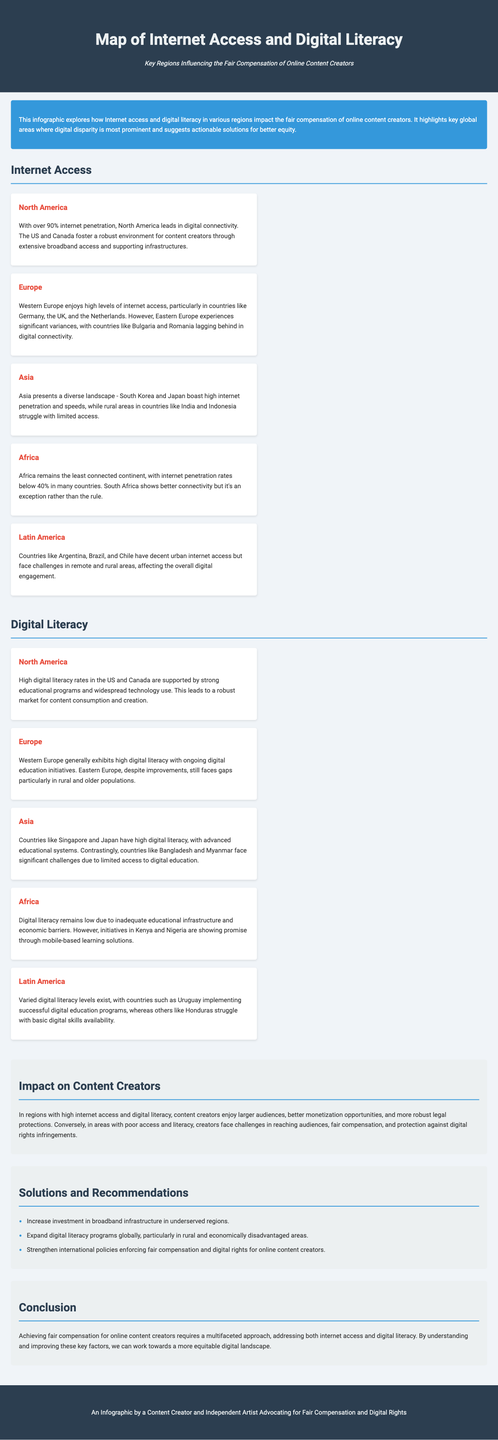What is the internet penetration rate in North America? North America has over 90% internet penetration, indicating a high level of digital connectivity.
Answer: over 90% Which region has the highest digital literacy? North America generally exhibits high digital literacy rates supported by strong educational programs.
Answer: North America What is one of the barriers to digital literacy in Africa? In Africa, digital literacy is low due to inadequate educational infrastructure and economic barriers.
Answer: Inadequate educational infrastructure Which country in Latin America has implemented successful digital education programs? Uruguay is noted for having implemented successful digital education programs within Latin America.
Answer: Uruguay What recommendation is given for improving internet access in underserved regions? The document recommends increasing investment in broadband infrastructure to improve access in underserved regions.
Answer: Increase investment in broadband infrastructure Which regions struggle with limited internet access? Rural areas in countries like India and Indonesia struggle with limited access to the internet.
Answer: Rural areas in India and Indonesia Which area is the least connected continent? Africa is identified as the least connected continent with many countries showing low internet penetration rates.
Answer: Africa What impact does high digital literacy have on content creators? High digital literacy in certain regions leads to larger audiences and better monetization opportunities for content creators.
Answer: Larger audiences and better monetization opportunities What type of approach is suggested for achieving fair compensation for content creators? A multifaceted approach is suggested to address both internet access and digital literacy to achieve fair compensation.
Answer: Multifaceted approach 